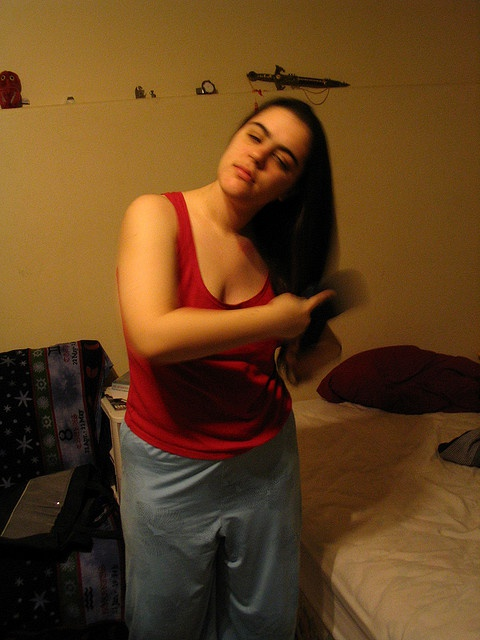Describe the objects in this image and their specific colors. I can see people in olive, black, maroon, gray, and brown tones, bed in olive, maroon, black, and gray tones, and chair in olive, black, and maroon tones in this image. 